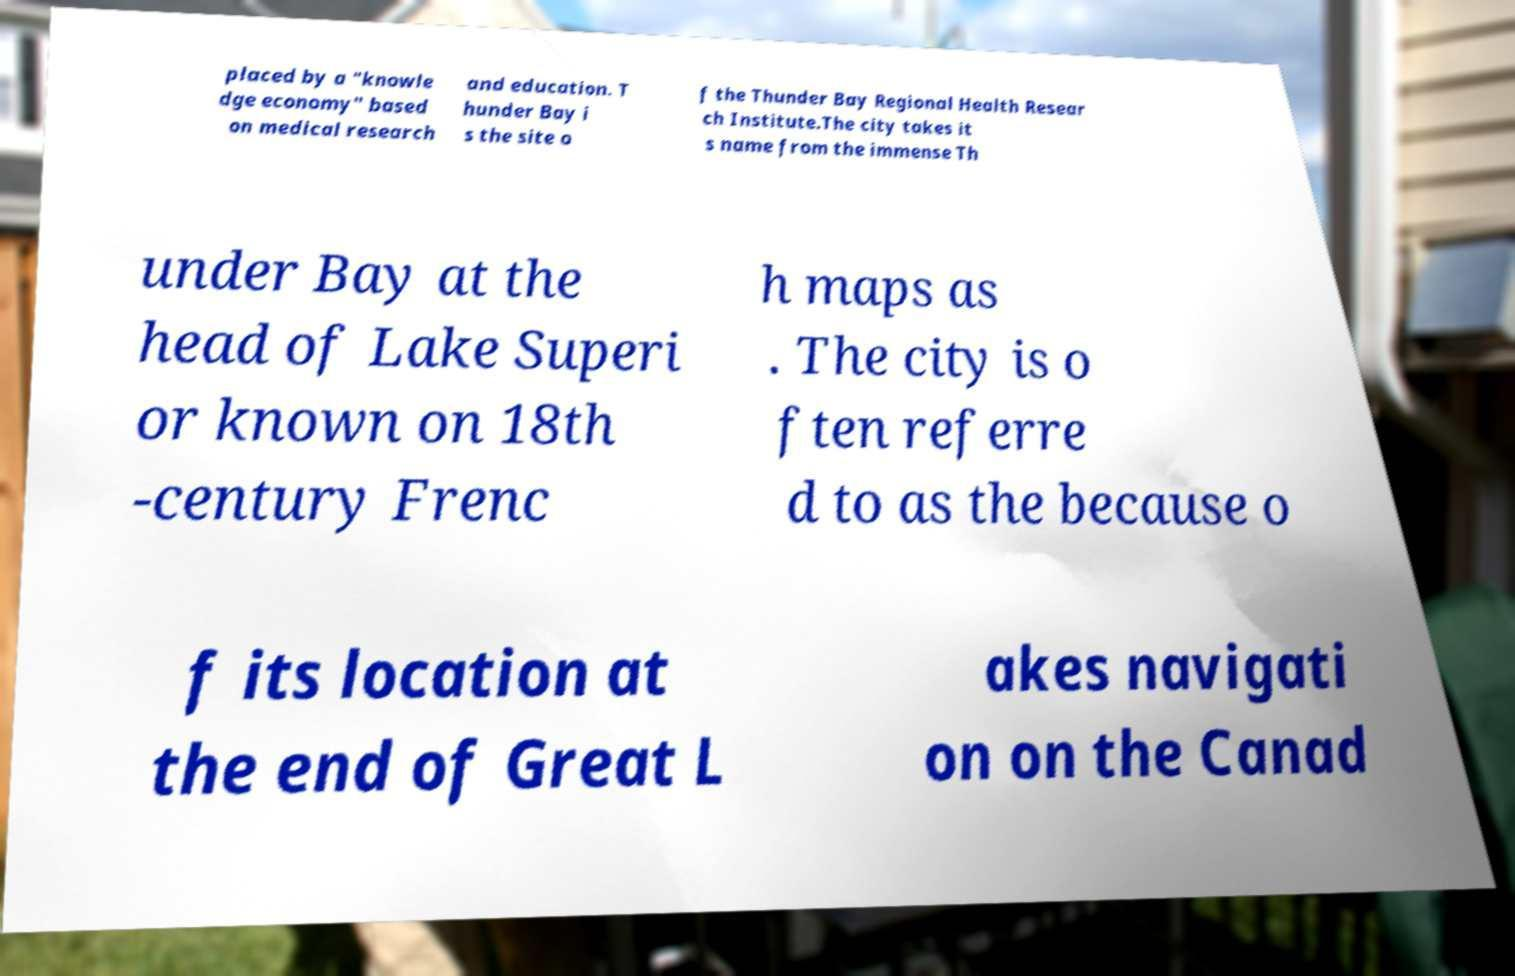I need the written content from this picture converted into text. Can you do that? placed by a "knowle dge economy" based on medical research and education. T hunder Bay i s the site o f the Thunder Bay Regional Health Resear ch Institute.The city takes it s name from the immense Th under Bay at the head of Lake Superi or known on 18th -century Frenc h maps as . The city is o ften referre d to as the because o f its location at the end of Great L akes navigati on on the Canad 